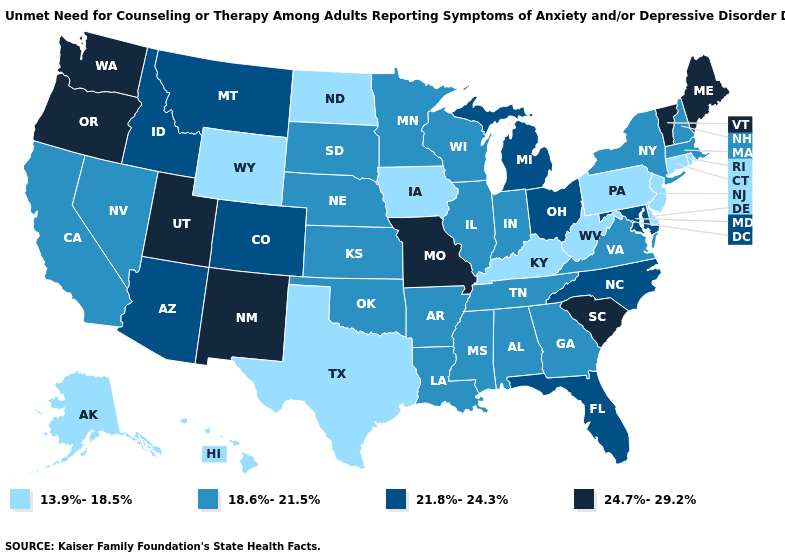Name the states that have a value in the range 24.7%-29.2%?
Answer briefly. Maine, Missouri, New Mexico, Oregon, South Carolina, Utah, Vermont, Washington. Among the states that border Massachusetts , which have the lowest value?
Quick response, please. Connecticut, Rhode Island. Does Nebraska have the lowest value in the USA?
Write a very short answer. No. Which states have the lowest value in the USA?
Concise answer only. Alaska, Connecticut, Delaware, Hawaii, Iowa, Kentucky, New Jersey, North Dakota, Pennsylvania, Rhode Island, Texas, West Virginia, Wyoming. Does Alabama have the lowest value in the South?
Write a very short answer. No. What is the value of Colorado?
Quick response, please. 21.8%-24.3%. What is the highest value in the USA?
Concise answer only. 24.7%-29.2%. Does Oklahoma have a higher value than North Dakota?
Quick response, please. Yes. Among the states that border Michigan , which have the lowest value?
Give a very brief answer. Indiana, Wisconsin. What is the value of Kansas?
Be succinct. 18.6%-21.5%. What is the highest value in states that border New Jersey?
Quick response, please. 18.6%-21.5%. Does Texas have the lowest value in the USA?
Write a very short answer. Yes. Among the states that border New Jersey , which have the lowest value?
Write a very short answer. Delaware, Pennsylvania. Does Michigan have the lowest value in the MidWest?
Short answer required. No. 